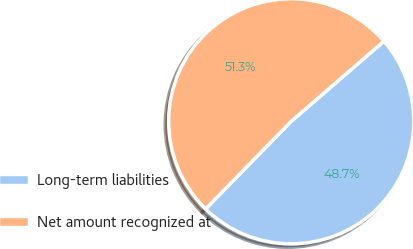Convert chart. <chart><loc_0><loc_0><loc_500><loc_500><pie_chart><fcel>Long-term liabilities<fcel>Net amount recognized at<nl><fcel>48.66%<fcel>51.34%<nl></chart> 